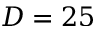<formula> <loc_0><loc_0><loc_500><loc_500>D = 2 5</formula> 